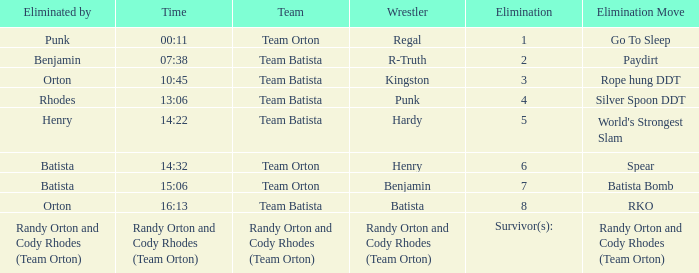What time was the Wrestler Henry eliminated by Batista? 14:32. 